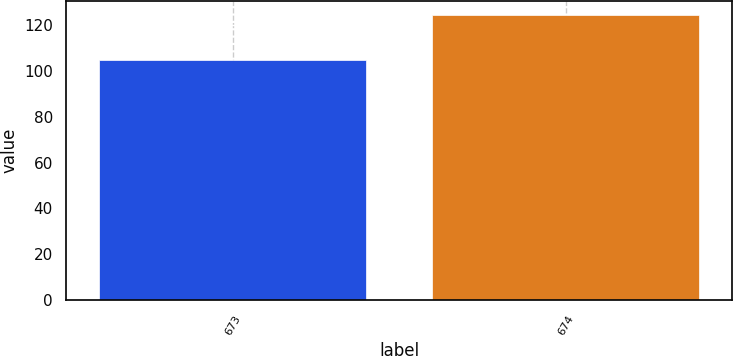Convert chart. <chart><loc_0><loc_0><loc_500><loc_500><bar_chart><fcel>673<fcel>674<nl><fcel>104.8<fcel>124.2<nl></chart> 